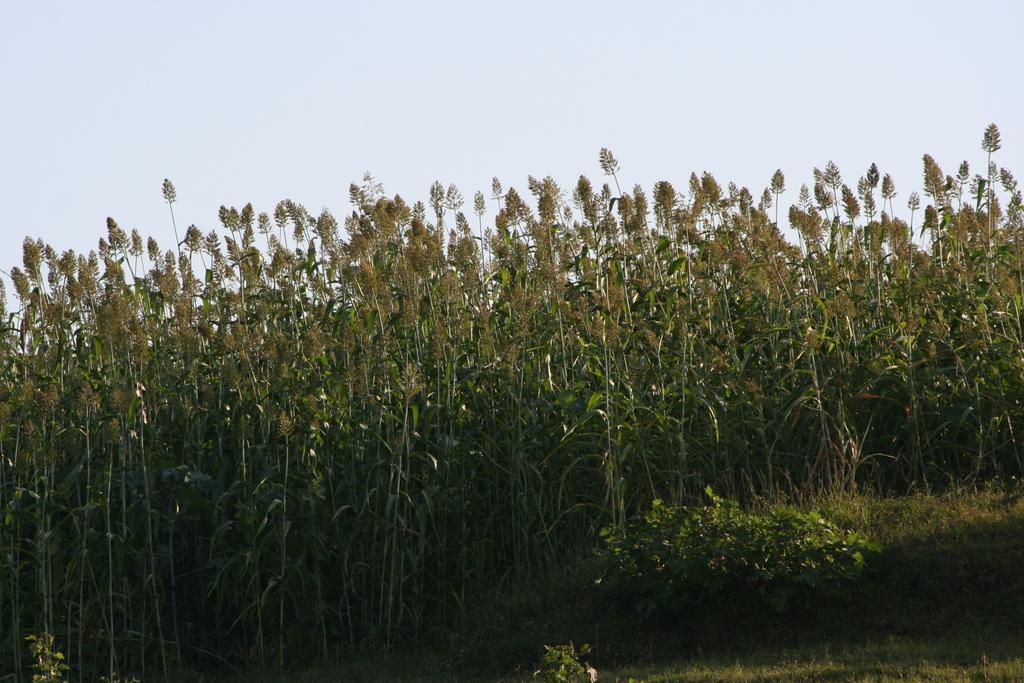Describe this image in one or two sentences. In this image I can see few trees which are green and brown in color and some grass. In the background I can see the sky. 